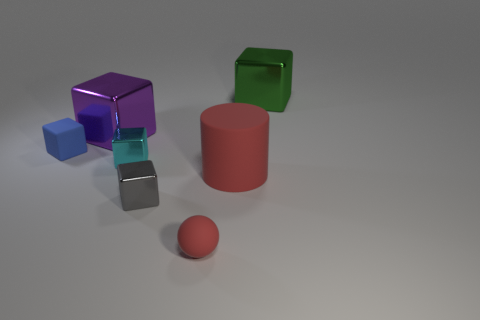Is the number of large yellow cylinders less than the number of small blue cubes?
Offer a terse response. Yes. Is there any other thing of the same color as the matte cylinder?
Your answer should be compact. Yes. There is a red object that is behind the matte sphere; what shape is it?
Offer a terse response. Cylinder. There is a small matte ball; does it have the same color as the big thing in front of the small rubber block?
Your response must be concise. Yes. Is the number of red rubber spheres behind the red sphere the same as the number of big metal objects that are right of the tiny cyan metal object?
Provide a short and direct response. No. What number of other things are the same size as the blue object?
Give a very brief answer. 3. The cyan metallic cube is what size?
Provide a short and direct response. Small. Does the small sphere have the same material as the large object in front of the tiny blue matte thing?
Offer a very short reply. Yes. Is there a tiny red matte object of the same shape as the purple metal thing?
Make the answer very short. No. What is the material of the gray block that is the same size as the cyan metallic thing?
Your answer should be compact. Metal. 